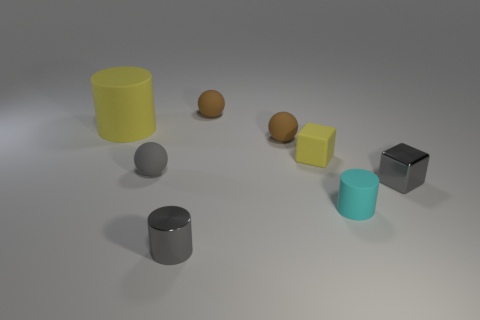Subtract all tiny brown matte spheres. How many spheres are left? 1 Subtract all blue blocks. How many brown balls are left? 2 Add 2 tiny gray metal blocks. How many objects exist? 10 Subtract all cylinders. How many objects are left? 5 Add 3 large gray rubber blocks. How many large gray rubber blocks exist? 3 Subtract 0 cyan blocks. How many objects are left? 8 Subtract 1 cubes. How many cubes are left? 1 Subtract all gray balls. Subtract all purple cylinders. How many balls are left? 2 Subtract all small metallic objects. Subtract all big rubber cylinders. How many objects are left? 5 Add 4 gray rubber objects. How many gray rubber objects are left? 5 